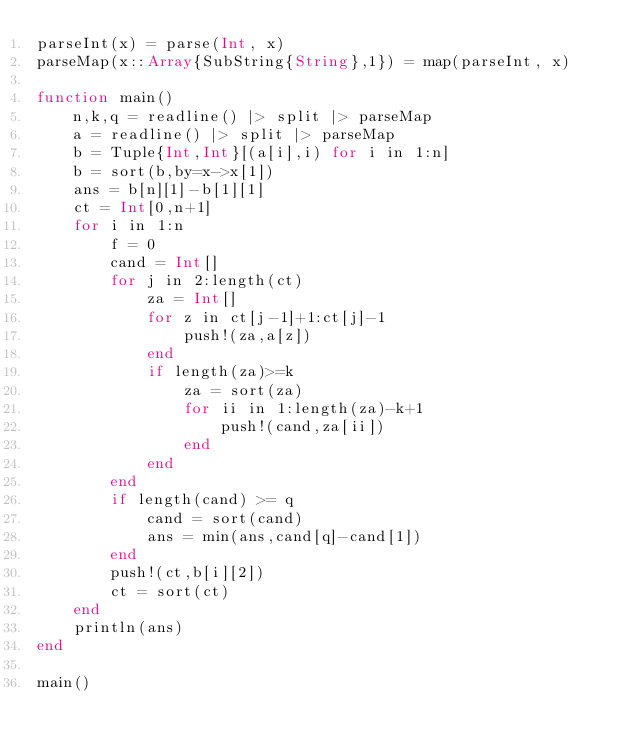<code> <loc_0><loc_0><loc_500><loc_500><_Julia_>parseInt(x) = parse(Int, x)
parseMap(x::Array{SubString{String},1}) = map(parseInt, x)

function main()
	n,k,q = readline() |> split |> parseMap
	a = readline() |> split |> parseMap
	b = Tuple{Int,Int}[(a[i],i) for i in 1:n]
	b = sort(b,by=x->x[1])
	ans = b[n][1]-b[1][1]
	ct = Int[0,n+1]
	for i in 1:n
		f = 0
		cand = Int[]
		for j in 2:length(ct)
			za = Int[]
			for z in ct[j-1]+1:ct[j]-1
				push!(za,a[z])
			end
			if length(za)>=k
				za = sort(za)
				for ii in 1:length(za)-k+1
					push!(cand,za[ii])
				end
			end
		end
		if length(cand) >= q
			cand = sort(cand)
			ans = min(ans,cand[q]-cand[1])
		end
		push!(ct,b[i][2])
		ct = sort(ct)
	end
	println(ans)
end

main()</code> 